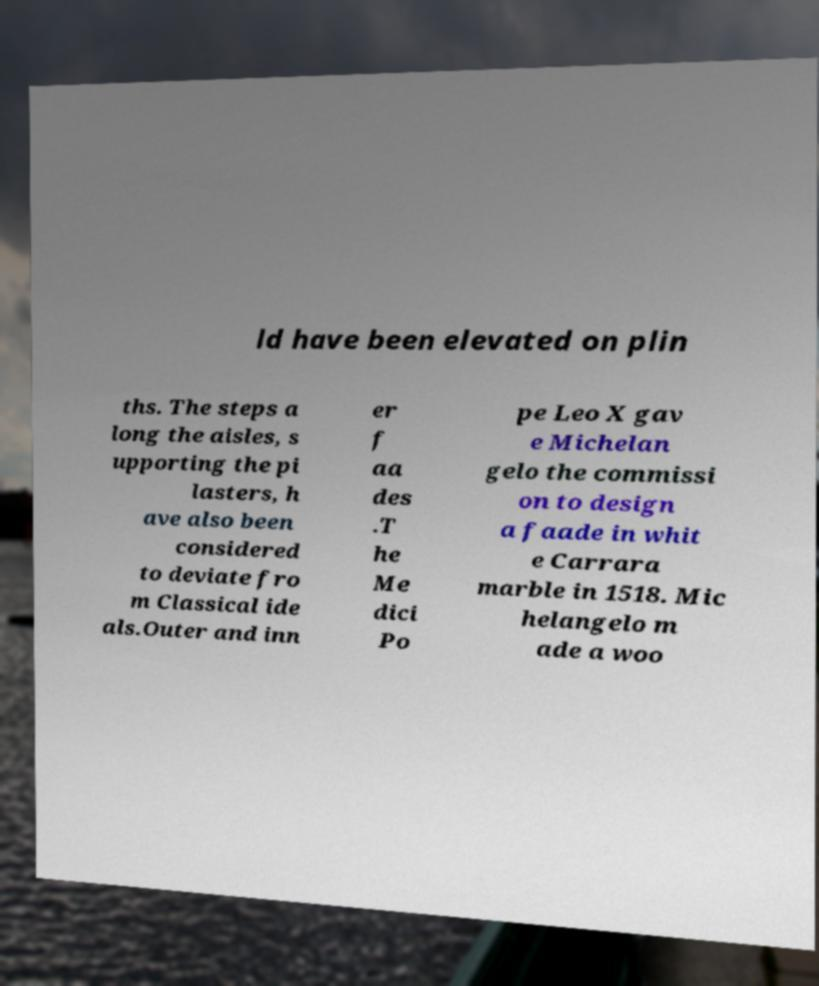Please read and relay the text visible in this image. What does it say? ld have been elevated on plin ths. The steps a long the aisles, s upporting the pi lasters, h ave also been considered to deviate fro m Classical ide als.Outer and inn er f aa des .T he Me dici Po pe Leo X gav e Michelan gelo the commissi on to design a faade in whit e Carrara marble in 1518. Mic helangelo m ade a woo 